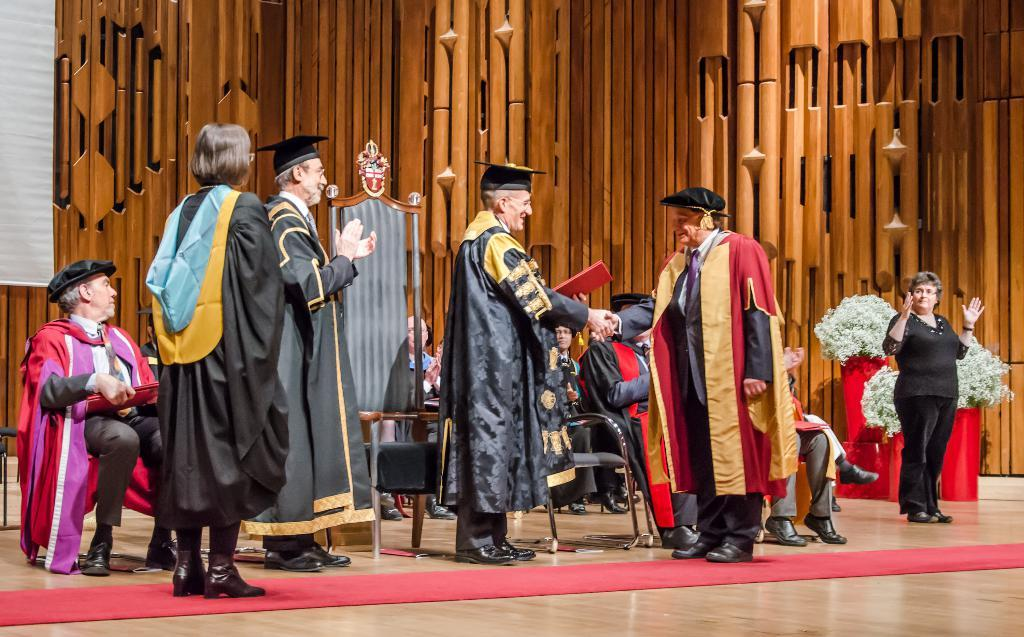Who or what can be seen in the image? There are people in the image. What type of vegetation is present on the right side of the image? There are flowers on the right side of the image. How many stars can be seen in the image? There are no stars visible in the image. What is the boy doing in the image? There is no boy present in the image. 